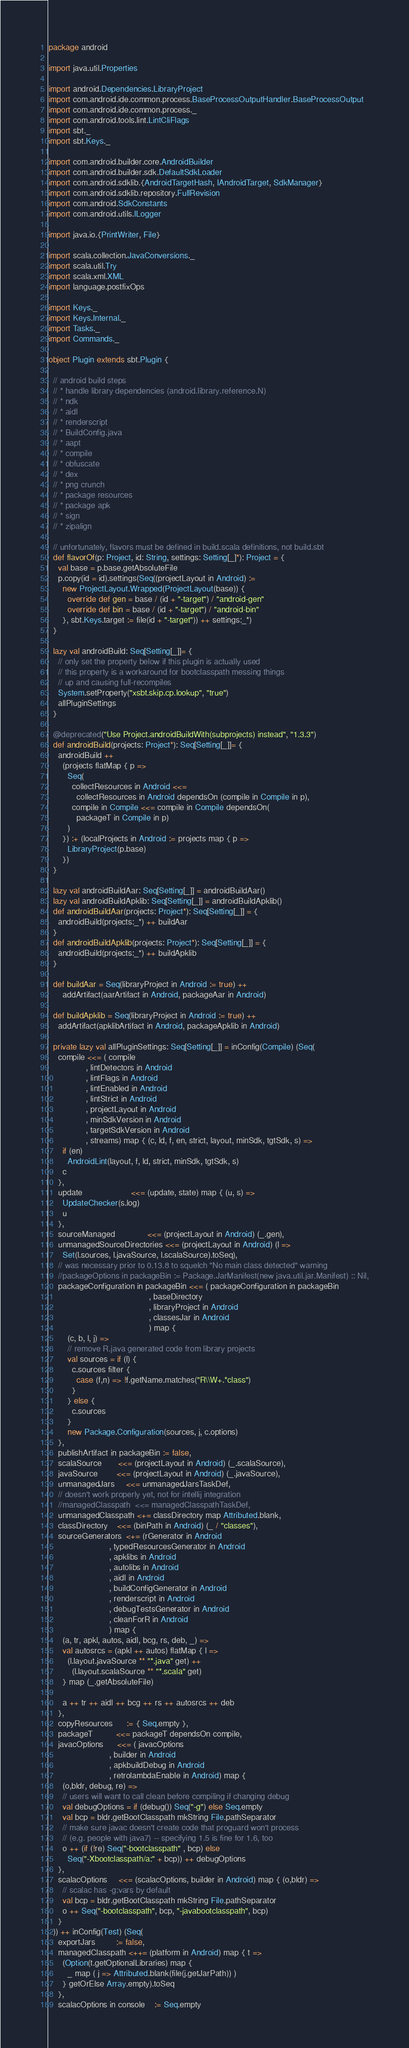Convert code to text. <code><loc_0><loc_0><loc_500><loc_500><_Scala_>package android

import java.util.Properties

import android.Dependencies.LibraryProject
import com.android.ide.common.process.BaseProcessOutputHandler.BaseProcessOutput
import com.android.ide.common.process._
import com.android.tools.lint.LintCliFlags
import sbt._
import sbt.Keys._

import com.android.builder.core.AndroidBuilder
import com.android.builder.sdk.DefaultSdkLoader
import com.android.sdklib.{AndroidTargetHash, IAndroidTarget, SdkManager}
import com.android.sdklib.repository.FullRevision
import com.android.SdkConstants
import com.android.utils.ILogger

import java.io.{PrintWriter, File}

import scala.collection.JavaConversions._
import scala.util.Try
import scala.xml.XML
import language.postfixOps

import Keys._
import Keys.Internal._
import Tasks._
import Commands._

object Plugin extends sbt.Plugin {

  // android build steps
  // * handle library dependencies (android.library.reference.N)
  // * ndk
  // * aidl
  // * renderscript
  // * BuildConfig.java
  // * aapt
  // * compile
  // * obfuscate
  // * dex
  // * png crunch
  // * package resources
  // * package apk
  // * sign
  // * zipalign

  // unfortunately, flavors must be defined in build.scala definitions, not build.sbt
  def flavorOf(p: Project, id: String, settings: Setting[_]*): Project = {
    val base = p.base.getAbsoluteFile
    p.copy(id = id).settings(Seq((projectLayout in Android) :=
      new ProjectLayout.Wrapped(ProjectLayout(base)) {
        override def gen = base / (id + "-target") / "android-gen"
        override def bin = base / (id + "-target") / "android-bin"
      }, sbt.Keys.target := file(id + "-target")) ++ settings:_*)
  }

  lazy val androidBuild: Seq[Setting[_]]= {
    // only set the property below if this plugin is actually used
    // this property is a workaround for bootclasspath messing things
    // up and causing full-recompiles
    System.setProperty("xsbt.skip.cp.lookup", "true")
    allPluginSettings
  }

  @deprecated("Use Project.androidBuildWith(subprojects) instead", "1.3.3")
  def androidBuild(projects: Project*): Seq[Setting[_]]= {
    androidBuild ++
      (projects flatMap { p =>
        Seq(
          collectResources in Android <<=
            collectResources in Android dependsOn (compile in Compile in p),
          compile in Compile <<= compile in Compile dependsOn(
            packageT in Compile in p)
        )
      }) :+ (localProjects in Android := projects map { p =>
        LibraryProject(p.base)
      })
  }

  lazy val androidBuildAar: Seq[Setting[_]] = androidBuildAar()
  lazy val androidBuildApklib: Seq[Setting[_]] = androidBuildApklib()
  def androidBuildAar(projects: Project*): Seq[Setting[_]] = {
    androidBuild(projects:_*) ++ buildAar
  }
  def androidBuildApklib(projects: Project*): Seq[Setting[_]] = {
    androidBuild(projects:_*) ++ buildApklib
  }

  def buildAar = Seq(libraryProject in Android := true) ++
      addArtifact(aarArtifact in Android, packageAar in Android)

  def buildApklib = Seq(libraryProject in Android := true) ++
    addArtifact(apklibArtifact in Android, packageApklib in Android)

  private lazy val allPluginSettings: Seq[Setting[_]] = inConfig(Compile) (Seq(
    compile <<= ( compile
                , lintDetectors in Android
                , lintFlags in Android
                , lintEnabled in Android
                , lintStrict in Android
                , projectLayout in Android
                , minSdkVersion in Android
                , targetSdkVersion in Android
                , streams) map { (c, ld, f, en, strict, layout, minSdk, tgtSdk, s) =>
      if (en)
        AndroidLint(layout, f, ld, strict, minSdk, tgtSdk, s)
      c
    },
    update                     <<= (update, state) map { (u, s) =>
      UpdateChecker(s.log)
      u
    },
    sourceManaged              <<= (projectLayout in Android) (_.gen),
    unmanagedSourceDirectories <<= (projectLayout in Android) (l =>
      Set(l.sources, l.javaSource, l.scalaSource).toSeq),
    // was necessary prior to 0.13.8 to squelch "No main class detected" warning
    //packageOptions in packageBin := Package.JarManifest(new java.util.jar.Manifest) :: Nil,
    packageConfiguration in packageBin <<= ( packageConfiguration in packageBin
                                           , baseDirectory
                                           , libraryProject in Android
                                           , classesJar in Android
                                           ) map {
        (c, b, l, j) =>
        // remove R.java generated code from library projects
        val sources = if (l) {
          c.sources filter {
            case (f,n) => !f.getName.matches("R\\W+.*class")
          }
        } else {
          c.sources
        }
        new Package.Configuration(sources, j, c.options)
    },
    publishArtifact in packageBin := false,
    scalaSource       <<= (projectLayout in Android) (_.scalaSource),
    javaSource        <<= (projectLayout in Android) (_.javaSource),
    unmanagedJars     <<= unmanagedJarsTaskDef,
    // doesn't work properly yet, not for intellij integration
    //managedClasspath  <<= managedClasspathTaskDef,
    unmanagedClasspath <+= classDirectory map Attributed.blank,
    classDirectory    <<= (binPath in Android) (_ / "classes"),
    sourceGenerators  <+= (rGenerator in Android
                          , typedResourcesGenerator in Android
                          , apklibs in Android
                          , autolibs in Android
                          , aidl in Android
                          , buildConfigGenerator in Android
                          , renderscript in Android
                          , debugTestsGenerator in Android
                          , cleanForR in Android
                          ) map {
      (a, tr, apkl, autos, aidl, bcg, rs, deb, _) =>
      val autosrcs = (apkl ++ autos) flatMap { l =>
        (l.layout.javaSource ** "*.java" get) ++
          (l.layout.scalaSource ** "*.scala" get)
      } map (_.getAbsoluteFile)

      a ++ tr ++ aidl ++ bcg ++ rs ++ autosrcs ++ deb
    },
    copyResources      := { Seq.empty },
    packageT          <<= packageT dependsOn compile,
    javacOptions      <<= ( javacOptions
                          , builder in Android
                          , apkbuildDebug in Android
                          , retrolambdaEnable in Android) map {
      (o,bldr, debug, re) =>
      // users will want to call clean before compiling if changing debug
      val debugOptions = if (debug()) Seq("-g") else Seq.empty
      val bcp = bldr.getBootClasspath mkString File.pathSeparator
      // make sure javac doesn't create code that proguard won't process
      // (e.g. people with java7) -- specifying 1.5 is fine for 1.6, too
      o ++ (if (!re) Seq("-bootclasspath" , bcp) else
        Seq("-Xbootclasspath/a:" + bcp)) ++ debugOptions
    },
    scalacOptions     <<= (scalacOptions, builder in Android) map { (o,bldr) =>
      // scalac has -g:vars by default
      val bcp = bldr.getBootClasspath mkString File.pathSeparator
      o ++ Seq("-bootclasspath", bcp, "-javabootclasspath", bcp)
    }
  )) ++ inConfig(Test) (Seq(
    exportJars         := false,
    managedClasspath <++= (platform in Android) map { t =>
      (Option(t.getOptionalLibraries) map {
        _ map ( j => Attributed.blank(file(j.getJarPath)) )
      } getOrElse Array.empty).toSeq
    },
    scalacOptions in console    := Seq.empty</code> 